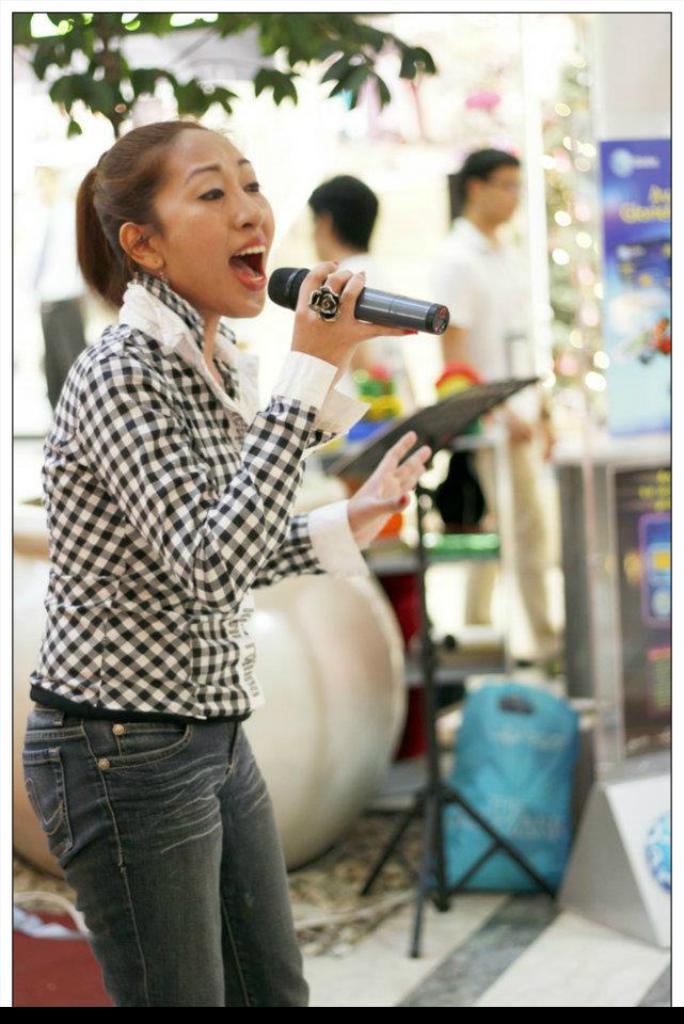Describe this image in one or two sentences. There is a girl in this picture talking holding a mic in her hand. In the background there are some people standing and there are some trees here. 